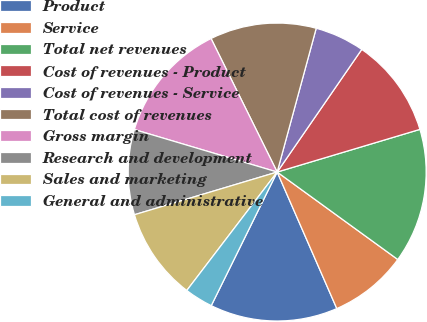<chart> <loc_0><loc_0><loc_500><loc_500><pie_chart><fcel>Product<fcel>Service<fcel>Total net revenues<fcel>Cost of revenues - Product<fcel>Cost of revenues - Service<fcel>Total cost of revenues<fcel>Gross margin<fcel>Research and development<fcel>Sales and marketing<fcel>General and administrative<nl><fcel>13.85%<fcel>8.46%<fcel>14.61%<fcel>10.77%<fcel>5.39%<fcel>11.54%<fcel>13.08%<fcel>9.23%<fcel>10.0%<fcel>3.08%<nl></chart> 